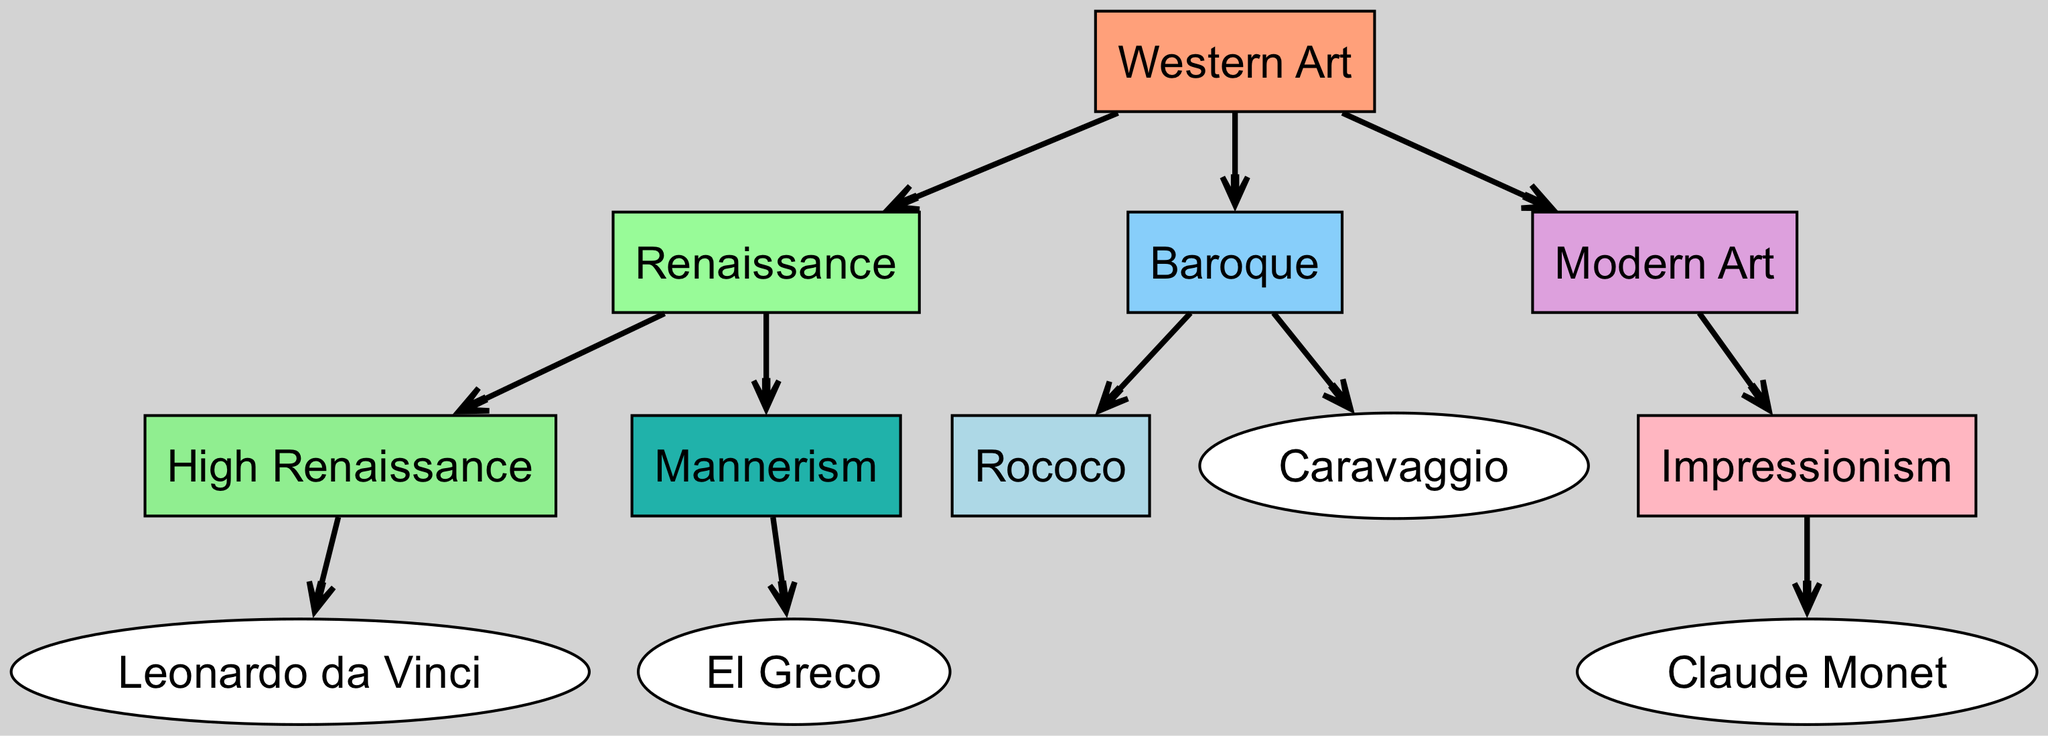What is the highest art movement shown in the diagram? The highest level in the hierarchy of this diagram represents "Western Art," which is the broadest category encompassing the subsequent movements.
Answer: Western Art How many edges are there in the diagram? The diagram contains multiple connections (edges) showing the relationships between nodes, which total to 10 edges.
Answer: 10 Which movement comes directly after Renaissance? According to the diagram's structure, "Modern Art" is the immediate successor to the "Renaissance."
Answer: Modern Art What is the primary style under the Renaissance? The diagram indicates that "High Renaissance" and "Mannerism" are branches that categorize the "Renaissance," but "High Renaissance" is typically regarded as the primary style.
Answer: High Renaissance Who are the four individual artists represented in the diagram? The artists included in the diagram are "Leonardo da Vinci," "El Greco," "Caravaggio," and "Claude Monet," as they are positioned as specific contributors to their respective movements.
Answer: Leonardo da Vinci, El Greco, Caravaggio, Claude Monet What art movement is directly connected to Impressionism? The diagram shows a direct connection from "Impressionism" to "Claude Monet," indicating that he is a key figure associated with this movement.
Answer: Claude Monet Which movement is associated with Caravaggio? The diagram highlights a direct link from "Caravaggio" to "Baroque," indicating that he is an influential artist within that movement.
Answer: Baroque How many movements are depicted in the Baroque level? Under the "Baroque" category, there are two styles represented: "Rococo" and "Caravaggio," resulting in a total of two movements.
Answer: 2 What color is used for the Modern Art node? The node for "Modern Art" in the diagram is filled with the color corresponding to the color scheme defined in the graph, which is purple.
Answer: Purple 